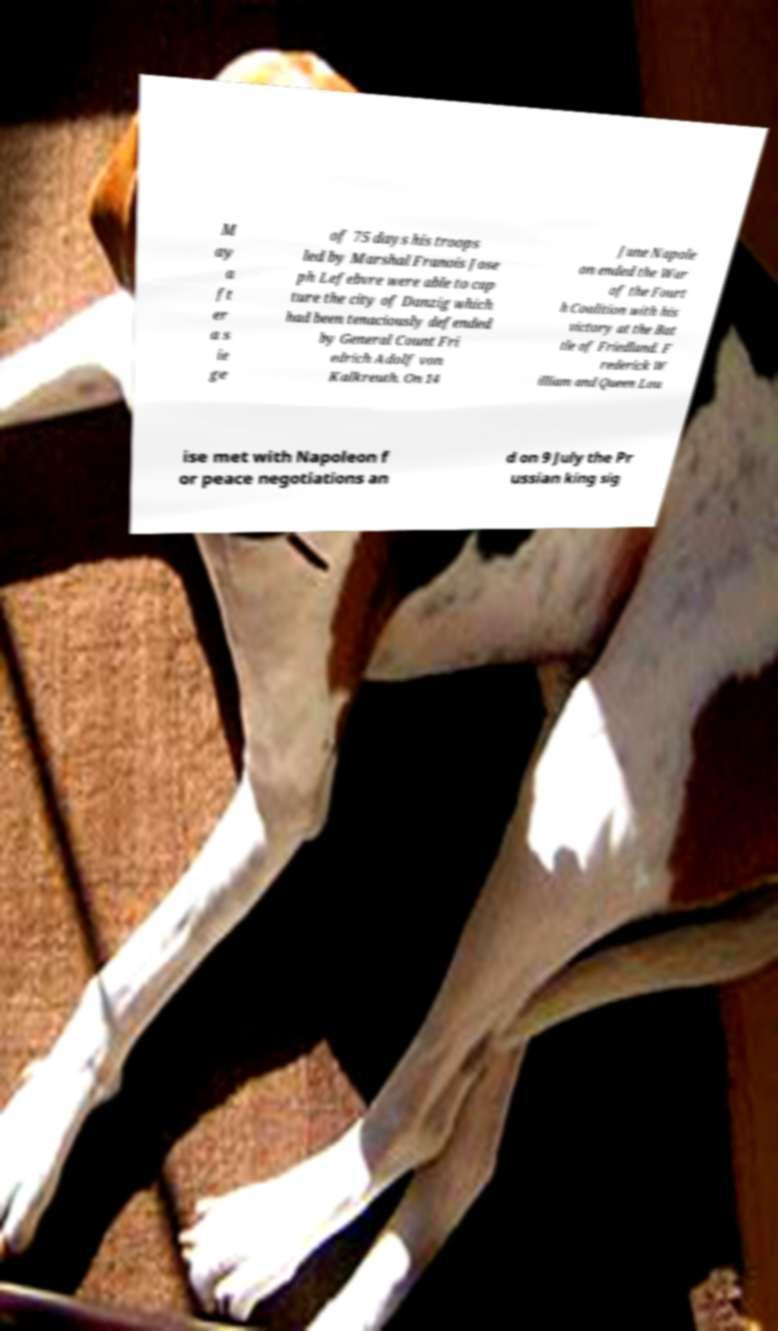Can you read and provide the text displayed in the image?This photo seems to have some interesting text. Can you extract and type it out for me? M ay a ft er a s ie ge of 75 days his troops led by Marshal Franois Jose ph Lefebvre were able to cap ture the city of Danzig which had been tenaciously defended by General Count Fri edrich Adolf von Kalkreuth. On 14 June Napole on ended the War of the Fourt h Coalition with his victory at the Bat tle of Friedland. F rederick W illiam and Queen Lou ise met with Napoleon f or peace negotiations an d on 9 July the Pr ussian king sig 